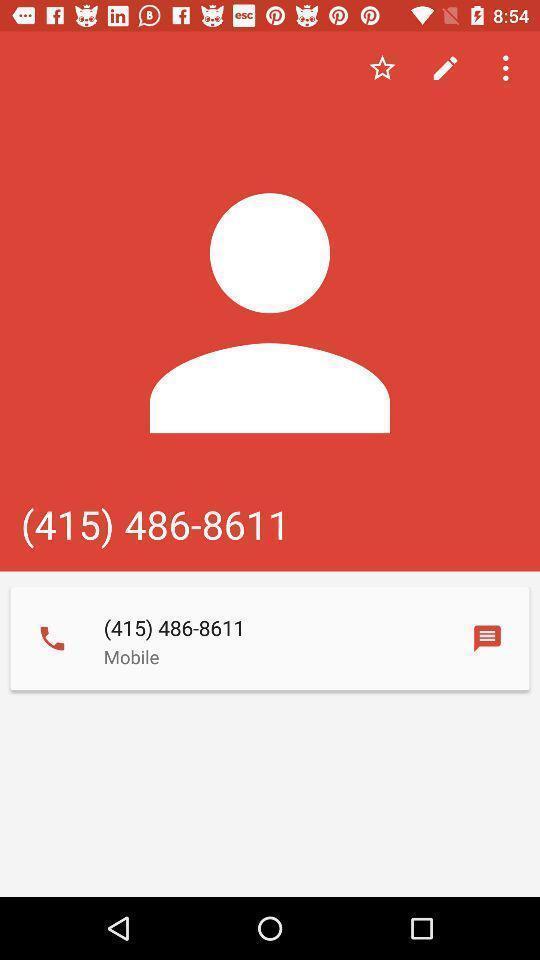Give me a summary of this screen capture. Screen shows contact details. 